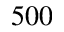Convert formula to latex. <formula><loc_0><loc_0><loc_500><loc_500>5 0 0</formula> 